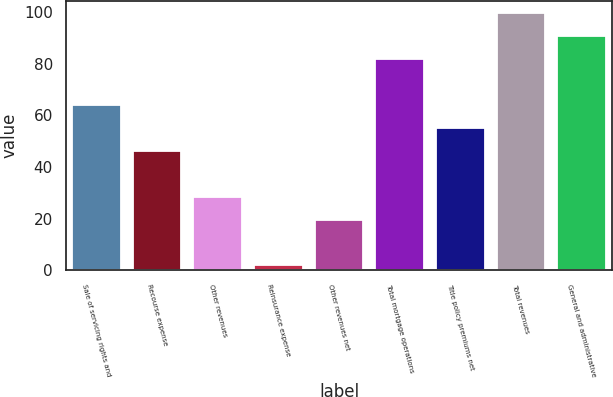Convert chart. <chart><loc_0><loc_0><loc_500><loc_500><bar_chart><fcel>Sale of servicing rights and<fcel>Recourse expense<fcel>Other revenues<fcel>Reinsurance expense<fcel>Other revenues net<fcel>Total mortgage operations<fcel>Title policy premiums net<fcel>Total revenues<fcel>General and administrative<nl><fcel>63.92<fcel>46.2<fcel>28.48<fcel>1.9<fcel>19.62<fcel>81.64<fcel>55.06<fcel>99.36<fcel>90.5<nl></chart> 